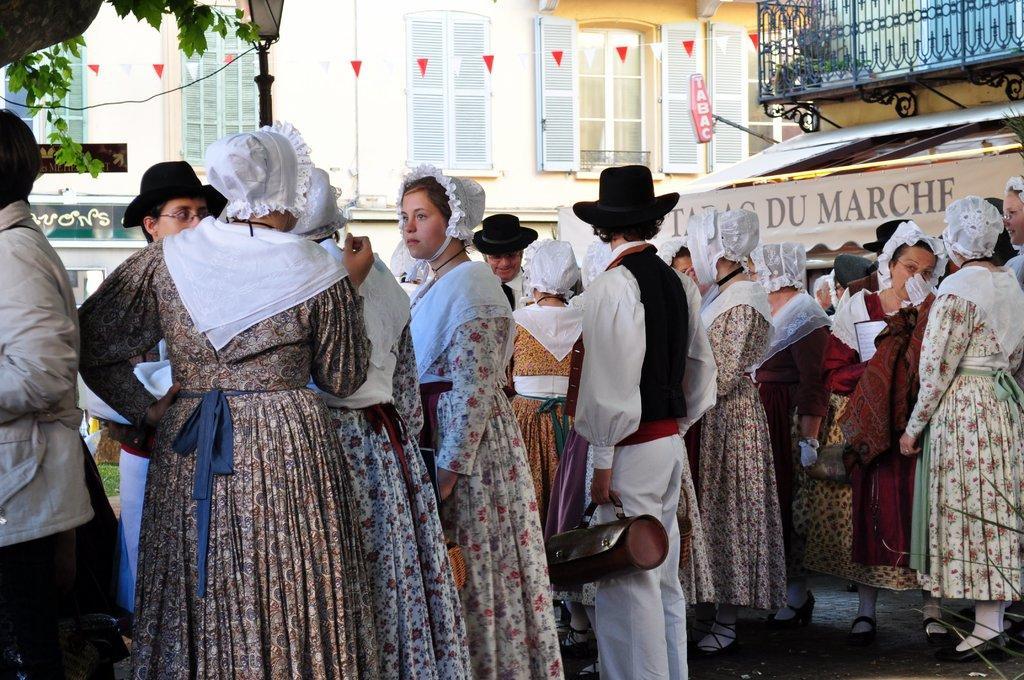Describe this image in one or two sentences. In this image, we can see a group of people standing. In the background, we can see street lights, building, metal grill, hoarding, glass window, plants. 